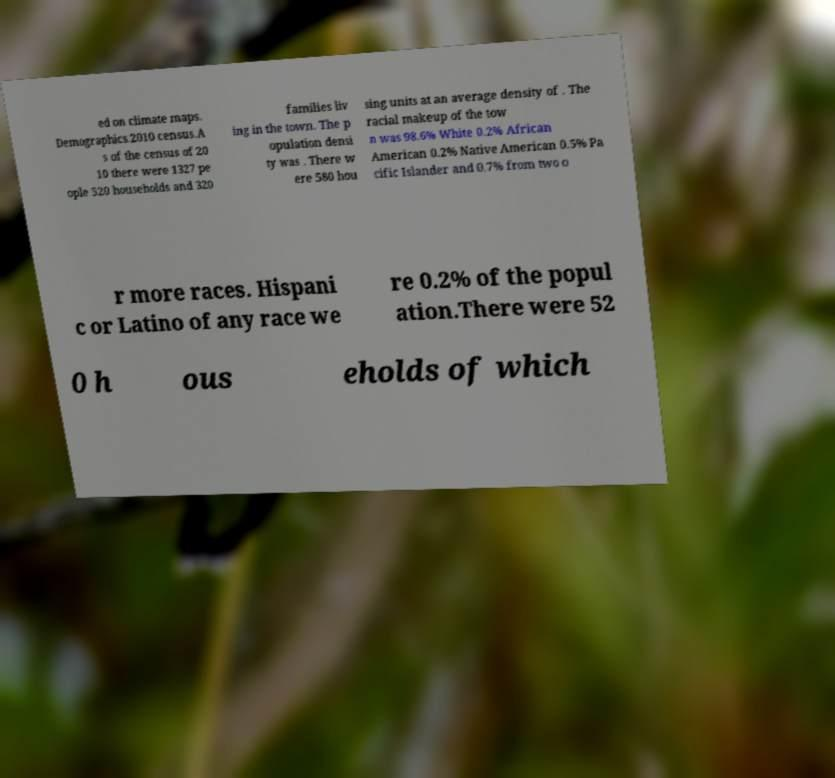Could you assist in decoding the text presented in this image and type it out clearly? ed on climate maps. Demographics.2010 census.A s of the census of 20 10 there were 1327 pe ople 520 households and 320 families liv ing in the town. The p opulation densi ty was . There w ere 580 hou sing units at an average density of . The racial makeup of the tow n was 98.6% White 0.2% African American 0.2% Native American 0.5% Pa cific Islander and 0.7% from two o r more races. Hispani c or Latino of any race we re 0.2% of the popul ation.There were 52 0 h ous eholds of which 